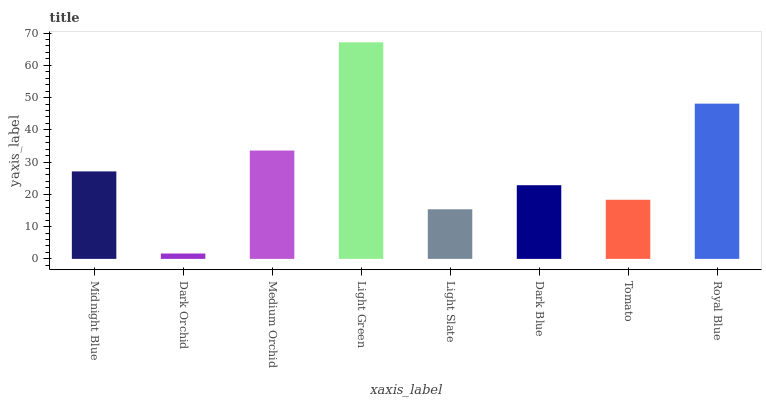Is Light Green the maximum?
Answer yes or no. Yes. Is Medium Orchid the minimum?
Answer yes or no. No. Is Medium Orchid the maximum?
Answer yes or no. No. Is Medium Orchid greater than Dark Orchid?
Answer yes or no. Yes. Is Dark Orchid less than Medium Orchid?
Answer yes or no. Yes. Is Dark Orchid greater than Medium Orchid?
Answer yes or no. No. Is Medium Orchid less than Dark Orchid?
Answer yes or no. No. Is Midnight Blue the high median?
Answer yes or no. Yes. Is Dark Blue the low median?
Answer yes or no. Yes. Is Light Green the high median?
Answer yes or no. No. Is Royal Blue the low median?
Answer yes or no. No. 